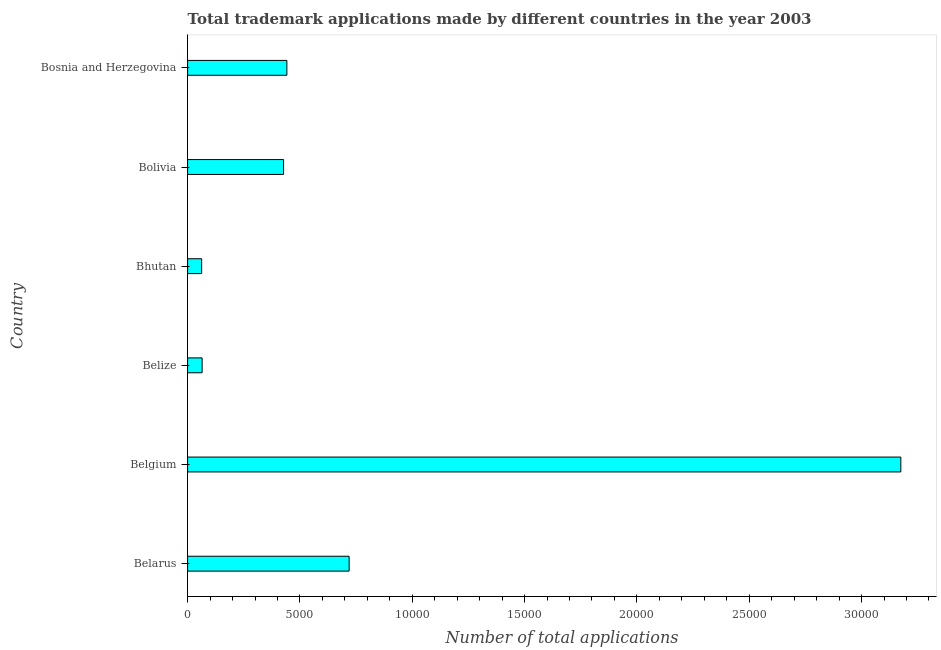Does the graph contain grids?
Give a very brief answer. No. What is the title of the graph?
Give a very brief answer. Total trademark applications made by different countries in the year 2003. What is the label or title of the X-axis?
Your answer should be very brief. Number of total applications. What is the number of trademark applications in Bolivia?
Keep it short and to the point. 4272. Across all countries, what is the maximum number of trademark applications?
Give a very brief answer. 3.17e+04. Across all countries, what is the minimum number of trademark applications?
Your answer should be compact. 626. In which country was the number of trademark applications maximum?
Provide a succinct answer. Belgium. In which country was the number of trademark applications minimum?
Offer a very short reply. Bhutan. What is the sum of the number of trademark applications?
Your answer should be compact. 4.89e+04. What is the average number of trademark applications per country?
Ensure brevity in your answer.  8150. What is the median number of trademark applications?
Your response must be concise. 4345.5. In how many countries, is the number of trademark applications greater than 16000 ?
Give a very brief answer. 1. What is the ratio of the number of trademark applications in Belgium to that in Bolivia?
Offer a very short reply. 7.43. Is the difference between the number of trademark applications in Belize and Bolivia greater than the difference between any two countries?
Your response must be concise. No. What is the difference between the highest and the second highest number of trademark applications?
Ensure brevity in your answer.  2.46e+04. What is the difference between the highest and the lowest number of trademark applications?
Make the answer very short. 3.11e+04. What is the difference between two consecutive major ticks on the X-axis?
Offer a terse response. 5000. What is the Number of total applications of Belarus?
Give a very brief answer. 7190. What is the Number of total applications in Belgium?
Provide a succinct answer. 3.17e+04. What is the Number of total applications in Belize?
Provide a short and direct response. 647. What is the Number of total applications in Bhutan?
Provide a succinct answer. 626. What is the Number of total applications of Bolivia?
Keep it short and to the point. 4272. What is the Number of total applications in Bosnia and Herzegovina?
Provide a succinct answer. 4419. What is the difference between the Number of total applications in Belarus and Belgium?
Give a very brief answer. -2.46e+04. What is the difference between the Number of total applications in Belarus and Belize?
Your answer should be compact. 6543. What is the difference between the Number of total applications in Belarus and Bhutan?
Your answer should be compact. 6564. What is the difference between the Number of total applications in Belarus and Bolivia?
Keep it short and to the point. 2918. What is the difference between the Number of total applications in Belarus and Bosnia and Herzegovina?
Keep it short and to the point. 2771. What is the difference between the Number of total applications in Belgium and Belize?
Keep it short and to the point. 3.11e+04. What is the difference between the Number of total applications in Belgium and Bhutan?
Provide a succinct answer. 3.11e+04. What is the difference between the Number of total applications in Belgium and Bolivia?
Offer a terse response. 2.75e+04. What is the difference between the Number of total applications in Belgium and Bosnia and Herzegovina?
Your answer should be very brief. 2.73e+04. What is the difference between the Number of total applications in Belize and Bhutan?
Provide a short and direct response. 21. What is the difference between the Number of total applications in Belize and Bolivia?
Give a very brief answer. -3625. What is the difference between the Number of total applications in Belize and Bosnia and Herzegovina?
Your answer should be compact. -3772. What is the difference between the Number of total applications in Bhutan and Bolivia?
Keep it short and to the point. -3646. What is the difference between the Number of total applications in Bhutan and Bosnia and Herzegovina?
Your response must be concise. -3793. What is the difference between the Number of total applications in Bolivia and Bosnia and Herzegovina?
Provide a succinct answer. -147. What is the ratio of the Number of total applications in Belarus to that in Belgium?
Your answer should be very brief. 0.23. What is the ratio of the Number of total applications in Belarus to that in Belize?
Ensure brevity in your answer.  11.11. What is the ratio of the Number of total applications in Belarus to that in Bhutan?
Your response must be concise. 11.49. What is the ratio of the Number of total applications in Belarus to that in Bolivia?
Your response must be concise. 1.68. What is the ratio of the Number of total applications in Belarus to that in Bosnia and Herzegovina?
Offer a terse response. 1.63. What is the ratio of the Number of total applications in Belgium to that in Belize?
Your response must be concise. 49.07. What is the ratio of the Number of total applications in Belgium to that in Bhutan?
Your answer should be compact. 50.71. What is the ratio of the Number of total applications in Belgium to that in Bolivia?
Your answer should be very brief. 7.43. What is the ratio of the Number of total applications in Belgium to that in Bosnia and Herzegovina?
Provide a short and direct response. 7.18. What is the ratio of the Number of total applications in Belize to that in Bhutan?
Provide a short and direct response. 1.03. What is the ratio of the Number of total applications in Belize to that in Bolivia?
Give a very brief answer. 0.15. What is the ratio of the Number of total applications in Belize to that in Bosnia and Herzegovina?
Provide a succinct answer. 0.15. What is the ratio of the Number of total applications in Bhutan to that in Bolivia?
Provide a succinct answer. 0.15. What is the ratio of the Number of total applications in Bhutan to that in Bosnia and Herzegovina?
Offer a terse response. 0.14. 